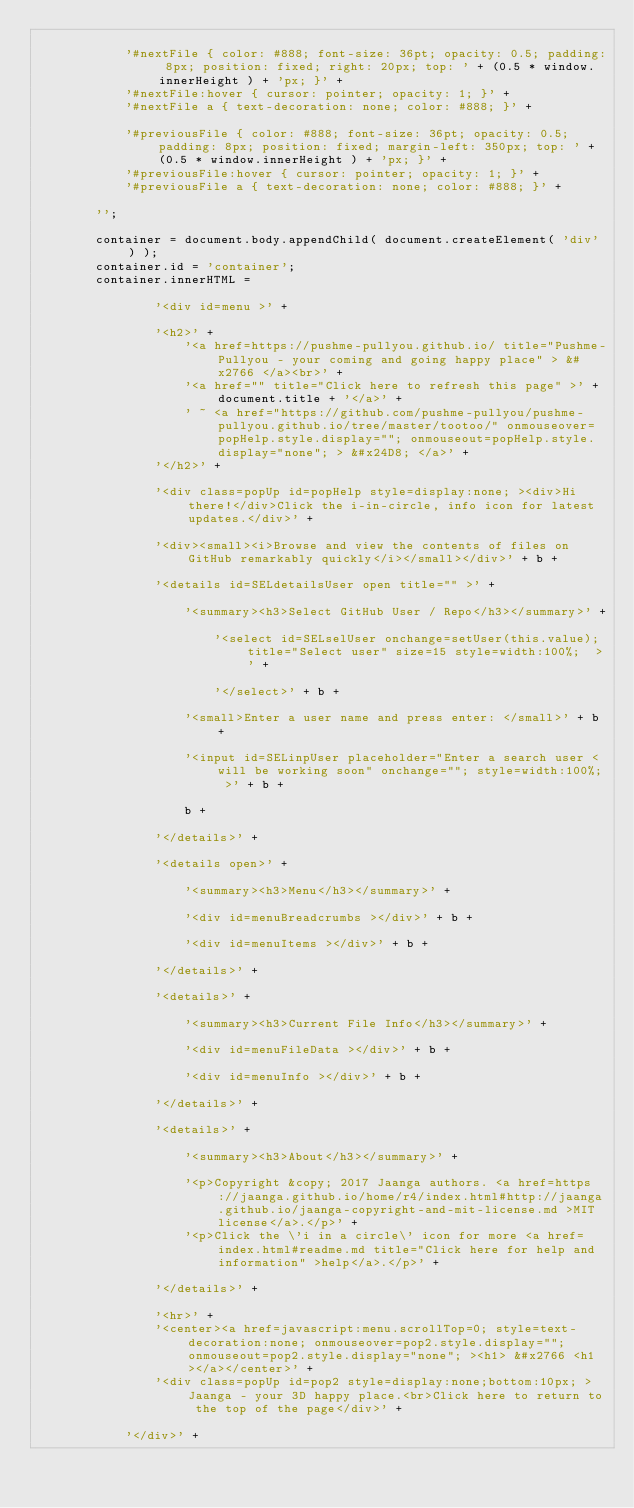<code> <loc_0><loc_0><loc_500><loc_500><_HTML_>
			'#nextFile { color: #888; font-size: 36pt; opacity: 0.5; padding: 8px; position: fixed; right: 20px; top: ' + (0.5 * window.innerHeight ) + 'px; }' +
			'#nextFile:hover { cursor: pointer; opacity: 1; }' +
			'#nextFile a { text-decoration: none; color: #888; }' +

			'#previousFile { color: #888; font-size: 36pt; opacity: 0.5; padding: 8px; position: fixed; margin-left: 350px; top: ' + (0.5 * window.innerHeight ) + 'px; }' +
			'#previousFile:hover { cursor: pointer; opacity: 1; }' +
			'#previousFile a { text-decoration: none; color: #888; }' +

		'';

		container = document.body.appendChild( document.createElement( 'div' ) );
		container.id = 'container';
		container.innerHTML =

				'<div id=menu >' +

				'<h2>' +
					'<a href=https://pushme-pullyou.github.io/ title="Pushme-Pullyou - your coming and going happy place" > &#x2766 </a><br>' +
					'<a href="" title="Click here to refresh this page" >' + document.title + '</a>' +
					' ~ <a href="https://github.com/pushme-pullyou/pushme-pullyou.github.io/tree/master/tootoo/" onmouseover=popHelp.style.display=""; onmouseout=popHelp.style.display="none"; > &#x24D8; </a>' +
				'</h2>' +

				'<div class=popUp id=popHelp style=display:none; ><div>Hi there!</div>Click the i-in-circle, info icon for latest updates.</div>' +

				'<div><small><i>Browse and view the contents of files on GitHub remarkably quickly</i></small></div>' + b +

				'<details id=SELdetailsUser open title="" >' +

					'<summary><h3>Select GitHub User / Repo</h3></summary>' +

						'<select id=SELselUser onchange=setUser(this.value); title="Select user" size=15 style=width:100%;  >' +

						'</select>' + b +

					'<small>Enter a user name and press enter: </small>' + b +

					'<input id=SELinpUser placeholder="Enter a search user < will be working soon" onchange=""; style=width:100%; >' + b +

					b +

				'</details>' +

				'<details open>' +

					'<summary><h3>Menu</h3></summary>' +

					'<div id=menuBreadcrumbs ></div>' + b +

					'<div id=menuItems ></div>' + b +

				'</details>' +

				'<details>' +

					'<summary><h3>Current File Info</h3></summary>' +

					'<div id=menuFileData ></div>' + b +

					'<div id=menuInfo ></div>' + b +

				'</details>' +

				'<details>' +

					'<summary><h3>About</h3></summary>' +

					'<p>Copyright &copy; 2017 Jaanga authors. <a href=https://jaanga.github.io/home/r4/index.html#http://jaanga.github.io/jaanga-copyright-and-mit-license.md >MIT license</a>.</p>' +
					'<p>Click the \'i in a circle\' icon for more <a href=index.html#readme.md title="Click here for help and information" >help</a>.</p>' +

				'</details>' +

				'<hr>' +
				'<center><a href=javascript:menu.scrollTop=0; style=text-decoration:none; onmouseover=pop2.style.display=""; onmouseout=pop2.style.display="none"; ><h1> &#x2766 <h1></a></center>' +
				'<div class=popUp id=pop2 style=display:none;bottom:10px; >Jaanga - your 3D happy place.<br>Click here to return to the top of the page</div>' +

			'</div>' +
</code> 